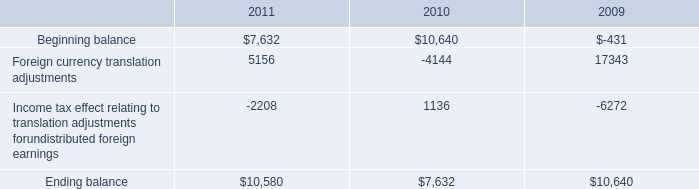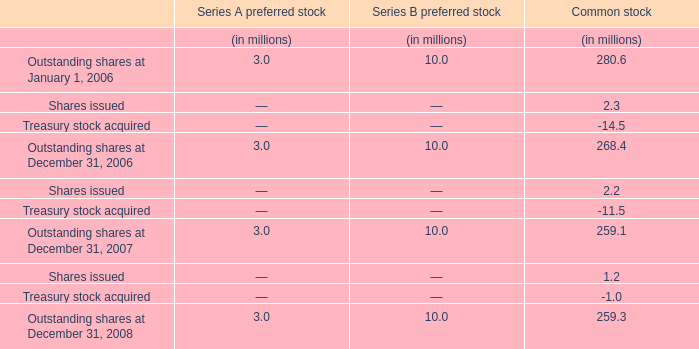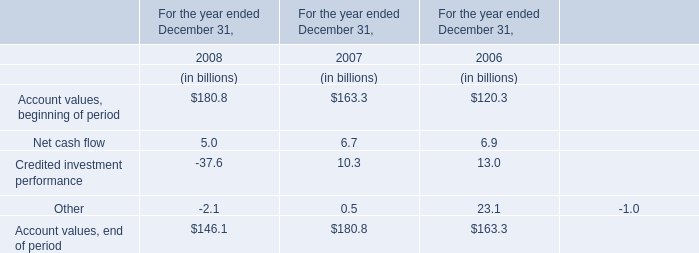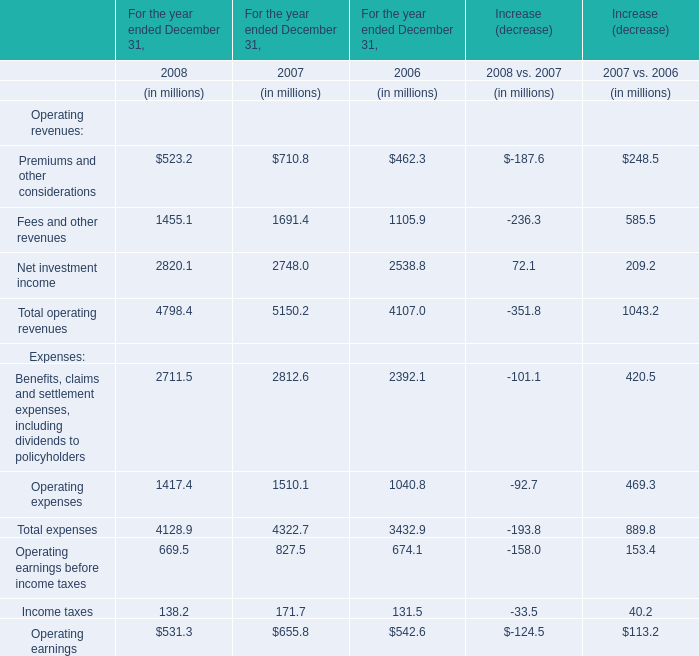In the year with the greatest proportion of Net investment income, what is the proportion of Net investment income to the total? (in %) 
Computations: (2538.8 / 4107)
Answer: 0.61816. 